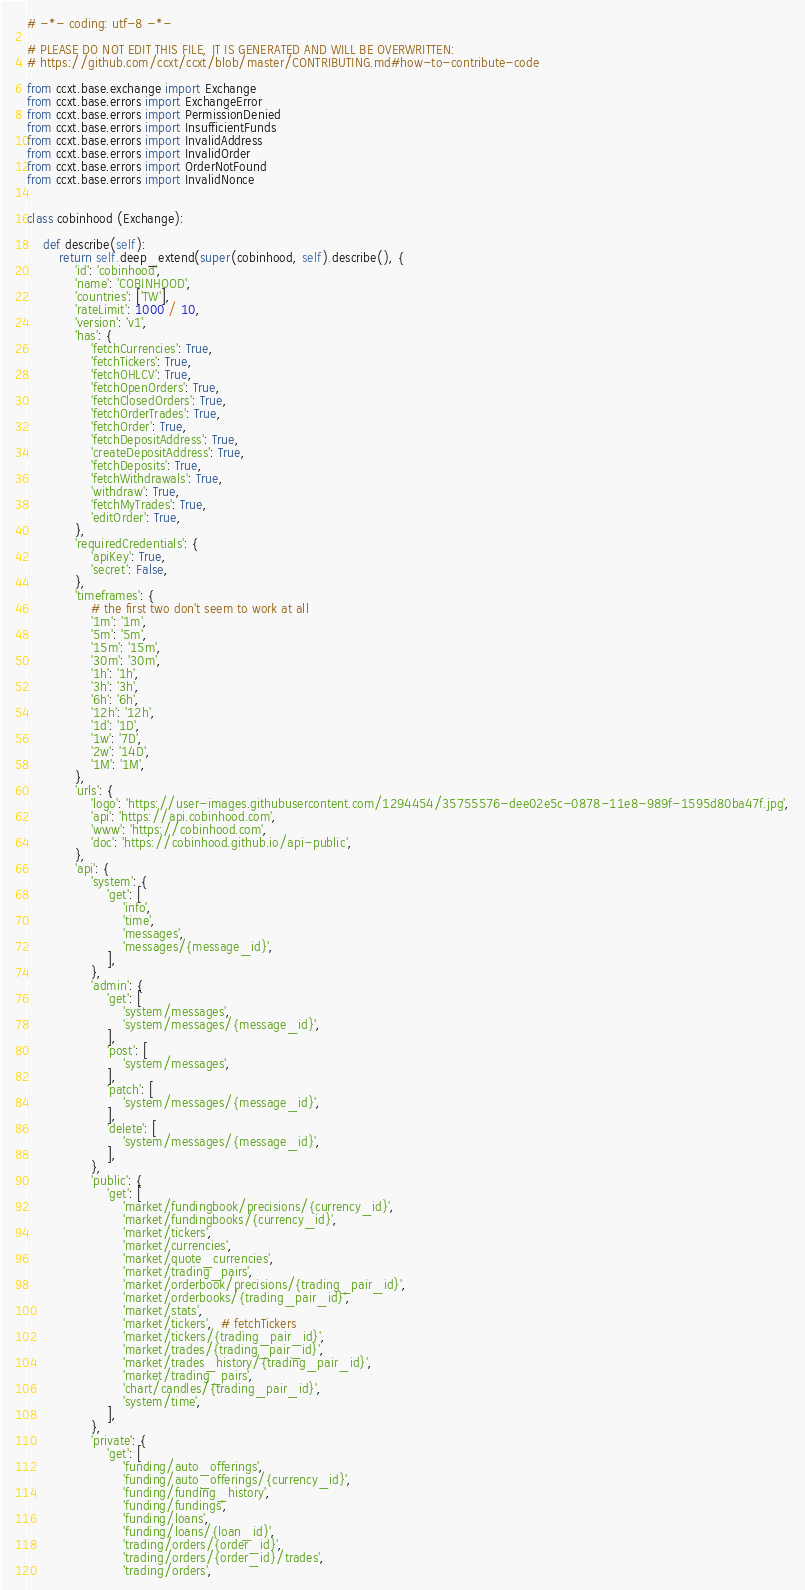<code> <loc_0><loc_0><loc_500><loc_500><_Python_># -*- coding: utf-8 -*-

# PLEASE DO NOT EDIT THIS FILE, IT IS GENERATED AND WILL BE OVERWRITTEN:
# https://github.com/ccxt/ccxt/blob/master/CONTRIBUTING.md#how-to-contribute-code

from ccxt.base.exchange import Exchange
from ccxt.base.errors import ExchangeError
from ccxt.base.errors import PermissionDenied
from ccxt.base.errors import InsufficientFunds
from ccxt.base.errors import InvalidAddress
from ccxt.base.errors import InvalidOrder
from ccxt.base.errors import OrderNotFound
from ccxt.base.errors import InvalidNonce


class cobinhood (Exchange):

    def describe(self):
        return self.deep_extend(super(cobinhood, self).describe(), {
            'id': 'cobinhood',
            'name': 'COBINHOOD',
            'countries': ['TW'],
            'rateLimit': 1000 / 10,
            'version': 'v1',
            'has': {
                'fetchCurrencies': True,
                'fetchTickers': True,
                'fetchOHLCV': True,
                'fetchOpenOrders': True,
                'fetchClosedOrders': True,
                'fetchOrderTrades': True,
                'fetchOrder': True,
                'fetchDepositAddress': True,
                'createDepositAddress': True,
                'fetchDeposits': True,
                'fetchWithdrawals': True,
                'withdraw': True,
                'fetchMyTrades': True,
                'editOrder': True,
            },
            'requiredCredentials': {
                'apiKey': True,
                'secret': False,
            },
            'timeframes': {
                # the first two don't seem to work at all
                '1m': '1m',
                '5m': '5m',
                '15m': '15m',
                '30m': '30m',
                '1h': '1h',
                '3h': '3h',
                '6h': '6h',
                '12h': '12h',
                '1d': '1D',
                '1w': '7D',
                '2w': '14D',
                '1M': '1M',
            },
            'urls': {
                'logo': 'https://user-images.githubusercontent.com/1294454/35755576-dee02e5c-0878-11e8-989f-1595d80ba47f.jpg',
                'api': 'https://api.cobinhood.com',
                'www': 'https://cobinhood.com',
                'doc': 'https://cobinhood.github.io/api-public',
            },
            'api': {
                'system': {
                    'get': [
                        'info',
                        'time',
                        'messages',
                        'messages/{message_id}',
                    ],
                },
                'admin': {
                    'get': [
                        'system/messages',
                        'system/messages/{message_id}',
                    ],
                    'post': [
                        'system/messages',
                    ],
                    'patch': [
                        'system/messages/{message_id}',
                    ],
                    'delete': [
                        'system/messages/{message_id}',
                    ],
                },
                'public': {
                    'get': [
                        'market/fundingbook/precisions/{currency_id}',
                        'market/fundingbooks/{currency_id}',
                        'market/tickers',
                        'market/currencies',
                        'market/quote_currencies',
                        'market/trading_pairs',
                        'market/orderbook/precisions/{trading_pair_id}',
                        'market/orderbooks/{trading_pair_id}',
                        'market/stats',
                        'market/tickers',  # fetchTickers
                        'market/tickers/{trading_pair_id}',
                        'market/trades/{trading_pair_id}',
                        'market/trades_history/{trading_pair_id}',
                        'market/trading_pairs',
                        'chart/candles/{trading_pair_id}',
                        'system/time',
                    ],
                },
                'private': {
                    'get': [
                        'funding/auto_offerings',
                        'funding/auto_offerings/{currency_id}',
                        'funding/funding_history',
                        'funding/fundings',
                        'funding/loans',
                        'funding/loans/{loan_id}',
                        'trading/orders/{order_id}',
                        'trading/orders/{order_id}/trades',
                        'trading/orders',</code> 